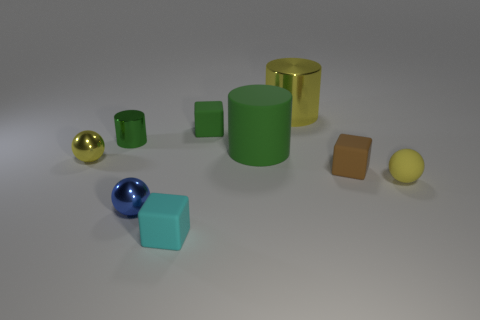What number of other objects are the same color as the large metal cylinder?
Give a very brief answer. 2. There is a big shiny thing; are there any small yellow spheres behind it?
Ensure brevity in your answer.  No. What number of things are either small yellow matte balls or matte objects that are in front of the tiny metallic cylinder?
Offer a terse response. 4. There is a ball that is to the right of the tiny cyan cube; are there any small yellow metal balls right of it?
Ensure brevity in your answer.  No. The small rubber object in front of the metal sphere in front of the yellow shiny thing that is in front of the green block is what shape?
Your answer should be very brief. Cube. What is the color of the shiny thing that is both in front of the large green rubber cylinder and left of the blue shiny thing?
Your answer should be very brief. Yellow. There is a small thing in front of the tiny blue shiny ball; what is its shape?
Give a very brief answer. Cube. There is a big yellow thing that is the same material as the blue sphere; what shape is it?
Your answer should be compact. Cylinder. What number of shiny things are either tiny brown blocks or green cylinders?
Offer a terse response. 1. What number of small things are left of the matte cylinder that is behind the yellow metal thing that is in front of the large metal object?
Your answer should be very brief. 5. 